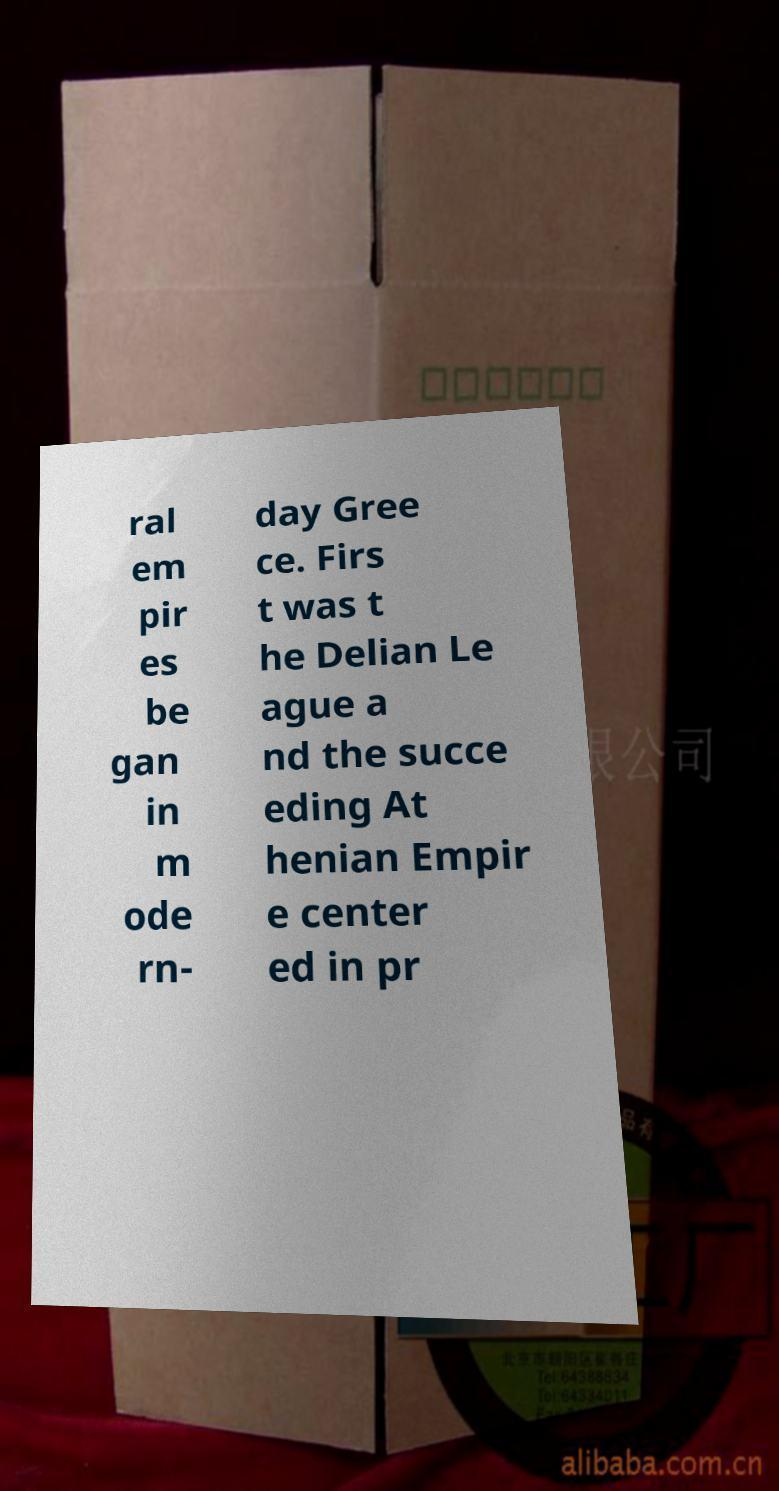There's text embedded in this image that I need extracted. Can you transcribe it verbatim? ral em pir es be gan in m ode rn- day Gree ce. Firs t was t he Delian Le ague a nd the succe eding At henian Empir e center ed in pr 